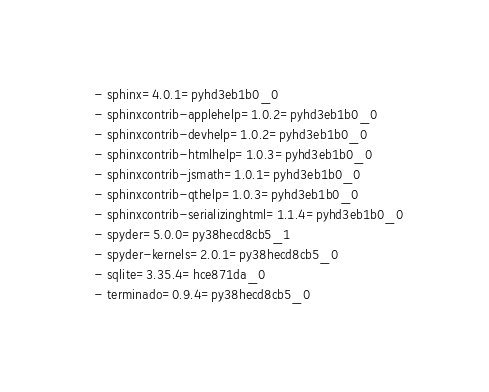<code> <loc_0><loc_0><loc_500><loc_500><_YAML_>  - sphinx=4.0.1=pyhd3eb1b0_0
  - sphinxcontrib-applehelp=1.0.2=pyhd3eb1b0_0
  - sphinxcontrib-devhelp=1.0.2=pyhd3eb1b0_0
  - sphinxcontrib-htmlhelp=1.0.3=pyhd3eb1b0_0
  - sphinxcontrib-jsmath=1.0.1=pyhd3eb1b0_0
  - sphinxcontrib-qthelp=1.0.3=pyhd3eb1b0_0
  - sphinxcontrib-serializinghtml=1.1.4=pyhd3eb1b0_0
  - spyder=5.0.0=py38hecd8cb5_1
  - spyder-kernels=2.0.1=py38hecd8cb5_0
  - sqlite=3.35.4=hce871da_0
  - terminado=0.9.4=py38hecd8cb5_0</code> 